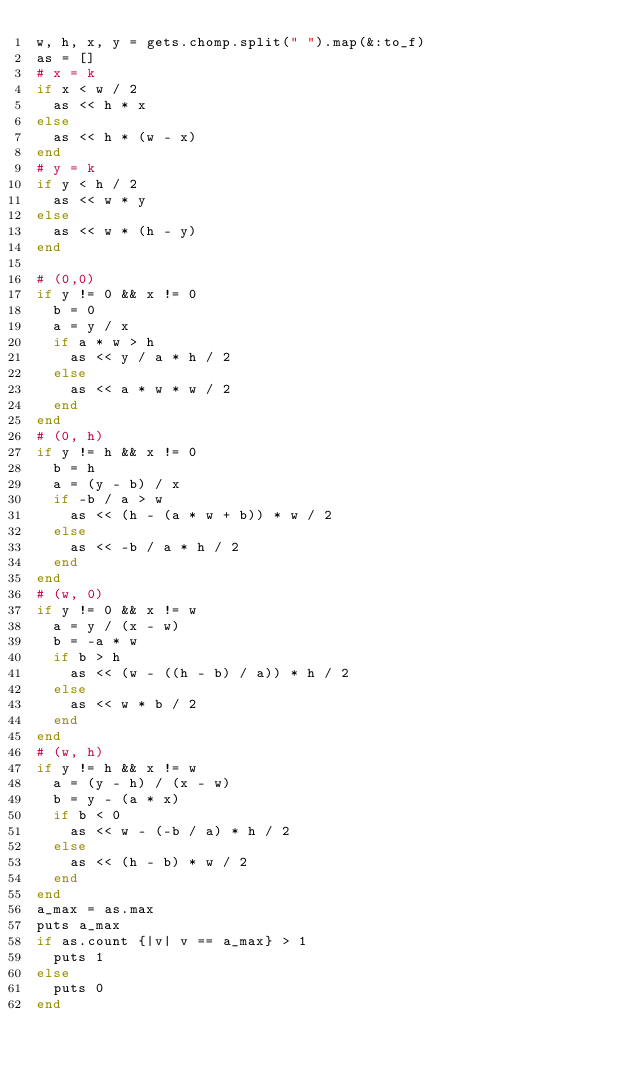<code> <loc_0><loc_0><loc_500><loc_500><_Ruby_>w, h, x, y = gets.chomp.split(" ").map(&:to_f)
as = []
# x = k
if x < w / 2
  as << h * x
else
  as << h * (w - x)
end
# y = k
if y < h / 2
  as << w * y
else
  as << w * (h - y)
end

# (0,0)
if y != 0 && x != 0
  b = 0
  a = y / x
  if a * w > h
    as << y / a * h / 2
  else
    as << a * w * w / 2
  end
end
# (0, h)
if y != h && x != 0
  b = h
  a = (y - b) / x
  if -b / a > w
    as << (h - (a * w + b)) * w / 2
  else
    as << -b / a * h / 2
  end
end
# (w, 0)
if y != 0 && x != w
  a = y / (x - w)
  b = -a * w
  if b > h
    as << (w - ((h - b) / a)) * h / 2
  else
    as << w * b / 2
  end
end
# (w, h)
if y != h && x != w
  a = (y - h) / (x - w)
  b = y - (a * x)
  if b < 0
    as << w - (-b / a) * h / 2
  else
    as << (h - b) * w / 2
  end
end
a_max = as.max
puts a_max
if as.count {|v| v == a_max} > 1
  puts 1
else
  puts 0
end
</code> 